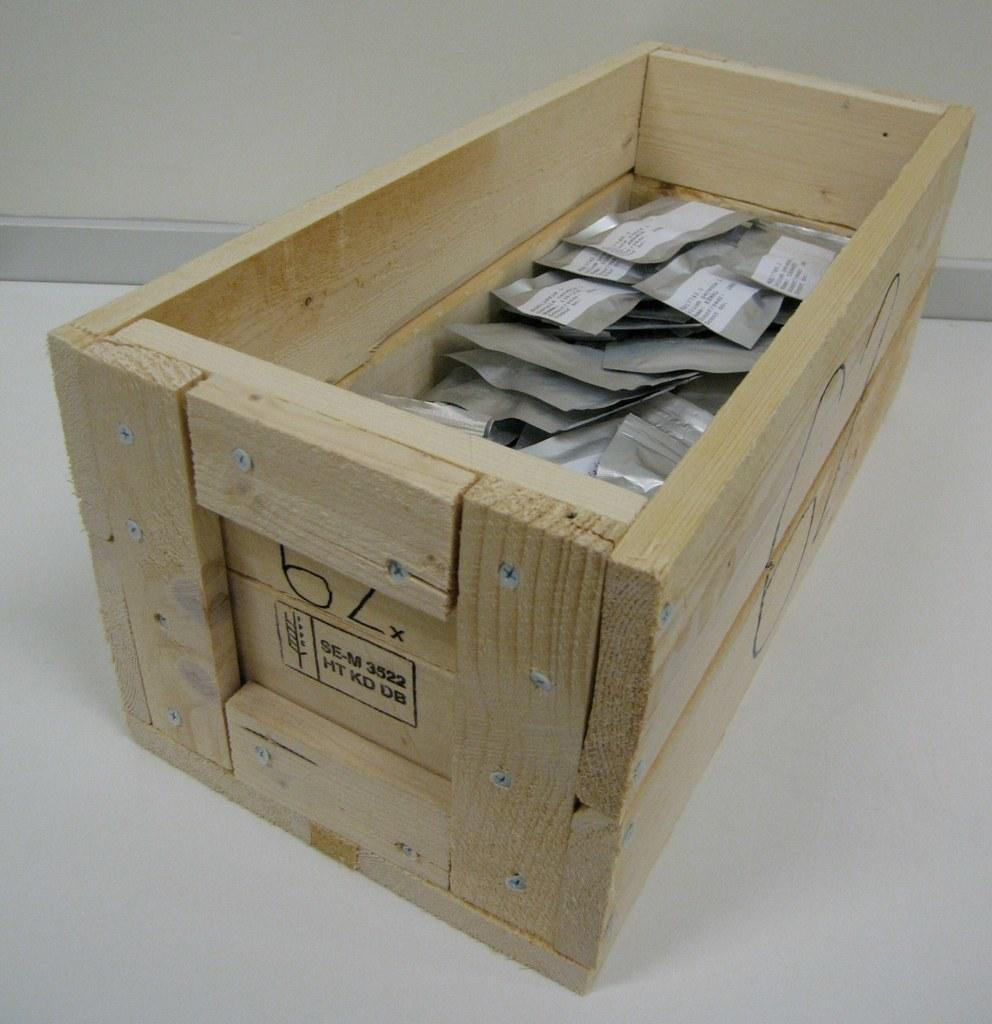<image>
Provide a brief description of the given image. A wooden crate labeled SE-M 3522 and containing small tan packets. 